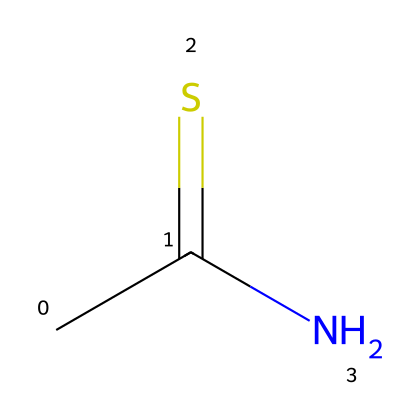What is the chemical name of the compound represented? The SMILES representation CC(=S)N corresponds to thioacetamide, where "C" represents carbon, "S" represents sulfur double-bonded to carbon, and "N" represents nitrogen.
Answer: thioacetamide How many carbon atoms are in this compound? Analyzing the SMILES, there are two "C" atoms present, indicating the number of carbon atoms in the compound.
Answer: 2 What functional group is present in thioacetamide? The presence of the sulfur atom bonded to carbon indicates the thio group in the chemical structure, giving it the characteristic of being a thioamide.
Answer: thio group What is the total number of bonds in this structure? The structure shows that there are three single bonds between carbon, nitrogen, and sulfur, and one double bond between carbon and sulfur, totaling four bonds in this molecular structure.
Answer: 4 Is thioacetamide a type of amide or thioamide? Given the presence of a sulfur atom in the structure, it is classified specifically as a thioamide, which is distinct from a regular amide that does not contain sulfur.
Answer: thioamide What is the hybridization of the carbon atom in this compound? The carbon in the thioacetamide structure is sp2 hybridized due to being bonded to one sulfur atom through a double bond and to one nitrogen atom, facilitating a planar arrangement which indicates sp2 hybridization.
Answer: sp2 What element is the least electronegative in this compound? Among carbon, sulfur, and nitrogen, carbon has the lowest electronegativity, indicating it is the least electronegative element in the compound.
Answer: carbon 